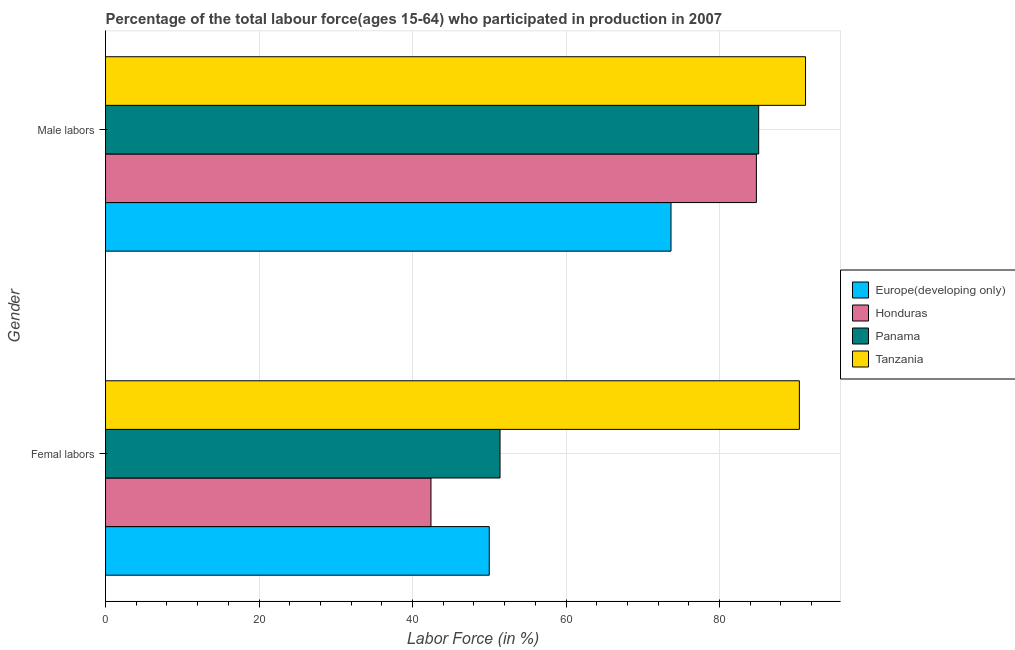How many different coloured bars are there?
Keep it short and to the point. 4. Are the number of bars per tick equal to the number of legend labels?
Offer a very short reply. Yes. How many bars are there on the 2nd tick from the top?
Your response must be concise. 4. How many bars are there on the 1st tick from the bottom?
Offer a very short reply. 4. What is the label of the 1st group of bars from the top?
Your response must be concise. Male labors. What is the percentage of female labor force in Tanzania?
Keep it short and to the point. 90.4. Across all countries, what is the maximum percentage of male labour force?
Ensure brevity in your answer.  91.2. Across all countries, what is the minimum percentage of female labor force?
Provide a succinct answer. 42.4. In which country was the percentage of female labor force maximum?
Your response must be concise. Tanzania. In which country was the percentage of female labor force minimum?
Provide a succinct answer. Honduras. What is the total percentage of female labor force in the graph?
Ensure brevity in your answer.  234.19. What is the difference between the percentage of female labor force in Honduras and that in Tanzania?
Keep it short and to the point. -48. What is the difference between the percentage of female labor force in Panama and the percentage of male labour force in Honduras?
Give a very brief answer. -33.4. What is the average percentage of male labour force per country?
Provide a short and direct response. 83.69. What is the difference between the percentage of female labor force and percentage of male labour force in Panama?
Provide a succinct answer. -33.7. In how many countries, is the percentage of male labour force greater than 12 %?
Make the answer very short. 4. What is the ratio of the percentage of female labor force in Tanzania to that in Honduras?
Your response must be concise. 2.13. What does the 4th bar from the top in Male labors represents?
Ensure brevity in your answer.  Europe(developing only). What does the 1st bar from the bottom in Male labors represents?
Keep it short and to the point. Europe(developing only). Are all the bars in the graph horizontal?
Offer a very short reply. Yes. Are the values on the major ticks of X-axis written in scientific E-notation?
Offer a very short reply. No. Does the graph contain any zero values?
Provide a short and direct response. No. Does the graph contain grids?
Offer a terse response. Yes. Where does the legend appear in the graph?
Your answer should be very brief. Center right. What is the title of the graph?
Make the answer very short. Percentage of the total labour force(ages 15-64) who participated in production in 2007. Does "Hong Kong" appear as one of the legend labels in the graph?
Offer a terse response. No. What is the label or title of the X-axis?
Your answer should be very brief. Labor Force (in %). What is the Labor Force (in %) in Europe(developing only) in Femal labors?
Ensure brevity in your answer.  49.99. What is the Labor Force (in %) in Honduras in Femal labors?
Your answer should be compact. 42.4. What is the Labor Force (in %) in Panama in Femal labors?
Keep it short and to the point. 51.4. What is the Labor Force (in %) in Tanzania in Femal labors?
Offer a terse response. 90.4. What is the Labor Force (in %) of Europe(developing only) in Male labors?
Offer a very short reply. 73.68. What is the Labor Force (in %) in Honduras in Male labors?
Your answer should be compact. 84.8. What is the Labor Force (in %) in Panama in Male labors?
Your answer should be very brief. 85.1. What is the Labor Force (in %) in Tanzania in Male labors?
Provide a short and direct response. 91.2. Across all Gender, what is the maximum Labor Force (in %) in Europe(developing only)?
Give a very brief answer. 73.68. Across all Gender, what is the maximum Labor Force (in %) in Honduras?
Offer a terse response. 84.8. Across all Gender, what is the maximum Labor Force (in %) in Panama?
Provide a short and direct response. 85.1. Across all Gender, what is the maximum Labor Force (in %) of Tanzania?
Your answer should be compact. 91.2. Across all Gender, what is the minimum Labor Force (in %) in Europe(developing only)?
Your answer should be compact. 49.99. Across all Gender, what is the minimum Labor Force (in %) in Honduras?
Provide a short and direct response. 42.4. Across all Gender, what is the minimum Labor Force (in %) of Panama?
Your response must be concise. 51.4. Across all Gender, what is the minimum Labor Force (in %) of Tanzania?
Make the answer very short. 90.4. What is the total Labor Force (in %) of Europe(developing only) in the graph?
Give a very brief answer. 123.67. What is the total Labor Force (in %) of Honduras in the graph?
Make the answer very short. 127.2. What is the total Labor Force (in %) in Panama in the graph?
Your answer should be very brief. 136.5. What is the total Labor Force (in %) of Tanzania in the graph?
Your response must be concise. 181.6. What is the difference between the Labor Force (in %) in Europe(developing only) in Femal labors and that in Male labors?
Give a very brief answer. -23.68. What is the difference between the Labor Force (in %) in Honduras in Femal labors and that in Male labors?
Provide a succinct answer. -42.4. What is the difference between the Labor Force (in %) in Panama in Femal labors and that in Male labors?
Offer a terse response. -33.7. What is the difference between the Labor Force (in %) of Tanzania in Femal labors and that in Male labors?
Ensure brevity in your answer.  -0.8. What is the difference between the Labor Force (in %) in Europe(developing only) in Femal labors and the Labor Force (in %) in Honduras in Male labors?
Your answer should be compact. -34.81. What is the difference between the Labor Force (in %) in Europe(developing only) in Femal labors and the Labor Force (in %) in Panama in Male labors?
Keep it short and to the point. -35.11. What is the difference between the Labor Force (in %) of Europe(developing only) in Femal labors and the Labor Force (in %) of Tanzania in Male labors?
Offer a terse response. -41.21. What is the difference between the Labor Force (in %) of Honduras in Femal labors and the Labor Force (in %) of Panama in Male labors?
Give a very brief answer. -42.7. What is the difference between the Labor Force (in %) of Honduras in Femal labors and the Labor Force (in %) of Tanzania in Male labors?
Your answer should be very brief. -48.8. What is the difference between the Labor Force (in %) of Panama in Femal labors and the Labor Force (in %) of Tanzania in Male labors?
Your response must be concise. -39.8. What is the average Labor Force (in %) in Europe(developing only) per Gender?
Offer a terse response. 61.83. What is the average Labor Force (in %) of Honduras per Gender?
Offer a terse response. 63.6. What is the average Labor Force (in %) of Panama per Gender?
Provide a short and direct response. 68.25. What is the average Labor Force (in %) in Tanzania per Gender?
Your answer should be compact. 90.8. What is the difference between the Labor Force (in %) in Europe(developing only) and Labor Force (in %) in Honduras in Femal labors?
Provide a succinct answer. 7.59. What is the difference between the Labor Force (in %) in Europe(developing only) and Labor Force (in %) in Panama in Femal labors?
Your answer should be compact. -1.41. What is the difference between the Labor Force (in %) in Europe(developing only) and Labor Force (in %) in Tanzania in Femal labors?
Your response must be concise. -40.41. What is the difference between the Labor Force (in %) in Honduras and Labor Force (in %) in Tanzania in Femal labors?
Ensure brevity in your answer.  -48. What is the difference between the Labor Force (in %) of Panama and Labor Force (in %) of Tanzania in Femal labors?
Keep it short and to the point. -39. What is the difference between the Labor Force (in %) in Europe(developing only) and Labor Force (in %) in Honduras in Male labors?
Ensure brevity in your answer.  -11.12. What is the difference between the Labor Force (in %) in Europe(developing only) and Labor Force (in %) in Panama in Male labors?
Your response must be concise. -11.42. What is the difference between the Labor Force (in %) of Europe(developing only) and Labor Force (in %) of Tanzania in Male labors?
Your answer should be very brief. -17.52. What is the difference between the Labor Force (in %) in Honduras and Labor Force (in %) in Panama in Male labors?
Provide a succinct answer. -0.3. What is the difference between the Labor Force (in %) in Honduras and Labor Force (in %) in Tanzania in Male labors?
Your answer should be compact. -6.4. What is the difference between the Labor Force (in %) of Panama and Labor Force (in %) of Tanzania in Male labors?
Offer a terse response. -6.1. What is the ratio of the Labor Force (in %) of Europe(developing only) in Femal labors to that in Male labors?
Give a very brief answer. 0.68. What is the ratio of the Labor Force (in %) in Honduras in Femal labors to that in Male labors?
Offer a very short reply. 0.5. What is the ratio of the Labor Force (in %) of Panama in Femal labors to that in Male labors?
Keep it short and to the point. 0.6. What is the difference between the highest and the second highest Labor Force (in %) in Europe(developing only)?
Your answer should be very brief. 23.68. What is the difference between the highest and the second highest Labor Force (in %) in Honduras?
Your answer should be very brief. 42.4. What is the difference between the highest and the second highest Labor Force (in %) of Panama?
Ensure brevity in your answer.  33.7. What is the difference between the highest and the lowest Labor Force (in %) in Europe(developing only)?
Provide a succinct answer. 23.68. What is the difference between the highest and the lowest Labor Force (in %) in Honduras?
Give a very brief answer. 42.4. What is the difference between the highest and the lowest Labor Force (in %) in Panama?
Give a very brief answer. 33.7. What is the difference between the highest and the lowest Labor Force (in %) of Tanzania?
Your response must be concise. 0.8. 